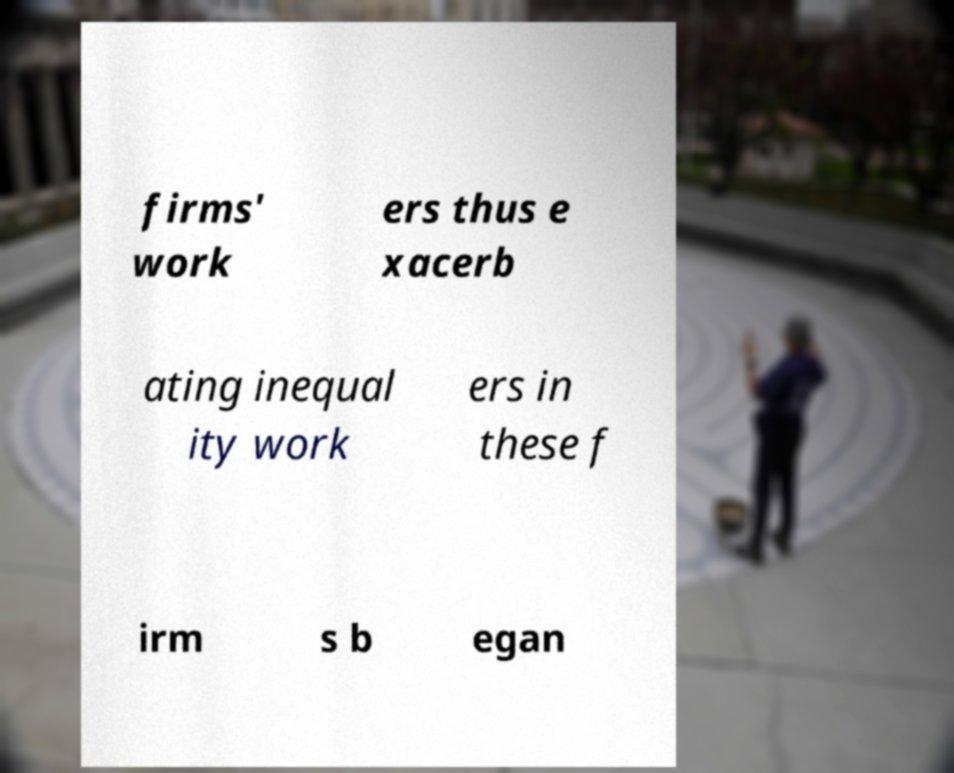Could you extract and type out the text from this image? firms' work ers thus e xacerb ating inequal ity work ers in these f irm s b egan 